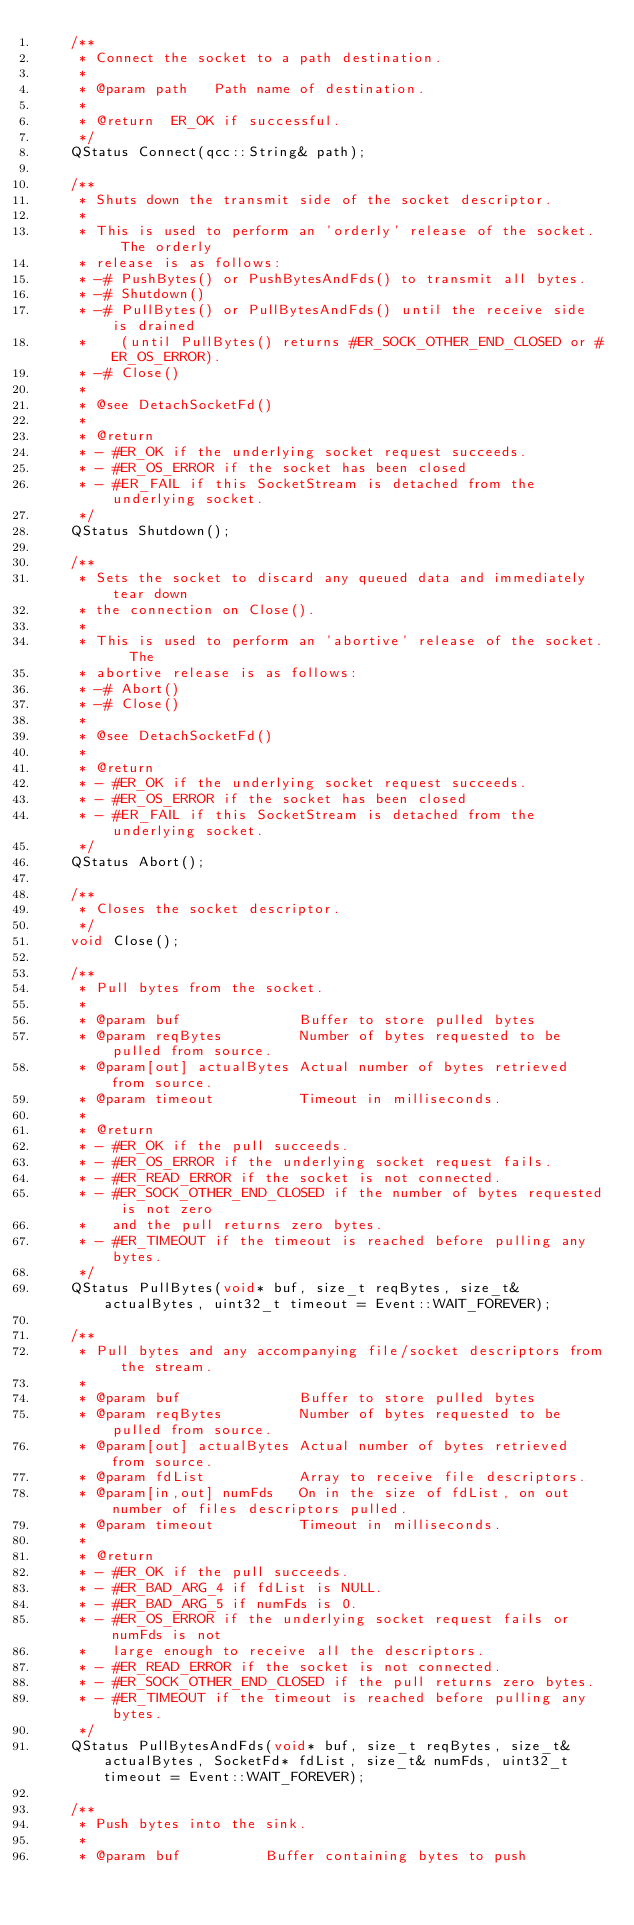Convert code to text. <code><loc_0><loc_0><loc_500><loc_500><_C_>    /**
     * Connect the socket to a path destination.
     *
     * @param path   Path name of destination.
     *
     * @return  ER_OK if successful.
     */
    QStatus Connect(qcc::String& path);

    /**
     * Shuts down the transmit side of the socket descriptor.
     *
     * This is used to perform an 'orderly' release of the socket.  The orderly
     * release is as follows:
     * -# PushBytes() or PushBytesAndFds() to transmit all bytes.
     * -# Shutdown()
     * -# PullBytes() or PullBytesAndFds() until the receive side is drained
     *    (until PullBytes() returns #ER_SOCK_OTHER_END_CLOSED or #ER_OS_ERROR).
     * -# Close()
     *
     * @see DetachSocketFd()
     *
     * @return
     * - #ER_OK if the underlying socket request succeeds.
     * - #ER_OS_ERROR if the socket has been closed
     * - #ER_FAIL if this SocketStream is detached from the underlying socket.
     */
    QStatus Shutdown();

    /**
     * Sets the socket to discard any queued data and immediately tear down
     * the connection on Close().
     *
     * This is used to perform an 'abortive' release of the socket.  The
     * abortive release is as follows:
     * -# Abort()
     * -# Close()
     *
     * @see DetachSocketFd()
     *
     * @return
     * - #ER_OK if the underlying socket request succeeds.
     * - #ER_OS_ERROR if the socket has been closed
     * - #ER_FAIL if this SocketStream is detached from the underlying socket.
     */
    QStatus Abort();

    /**
     * Closes the socket descriptor.
     */
    void Close();

    /**
     * Pull bytes from the socket.
     *
     * @param buf              Buffer to store pulled bytes
     * @param reqBytes         Number of bytes requested to be pulled from source.
     * @param[out] actualBytes Actual number of bytes retrieved from source.
     * @param timeout          Timeout in milliseconds.
     *
     * @return
     * - #ER_OK if the pull succeeds.
     * - #ER_OS_ERROR if the underlying socket request fails.
     * - #ER_READ_ERROR if the socket is not connected.
     * - #ER_SOCK_OTHER_END_CLOSED if the number of bytes requested is not zero
     *   and the pull returns zero bytes.
     * - #ER_TIMEOUT if the timeout is reached before pulling any bytes.
     */
    QStatus PullBytes(void* buf, size_t reqBytes, size_t& actualBytes, uint32_t timeout = Event::WAIT_FOREVER);

    /**
     * Pull bytes and any accompanying file/socket descriptors from the stream.
     *
     * @param buf              Buffer to store pulled bytes
     * @param reqBytes         Number of bytes requested to be pulled from source.
     * @param[out] actualBytes Actual number of bytes retrieved from source.
     * @param fdList           Array to receive file descriptors.
     * @param[in,out] numFds   On in the size of fdList, on out number of files descriptors pulled.
     * @param timeout          Timeout in milliseconds.
     *
     * @return
     * - #ER_OK if the pull succeeds.
     * - #ER_BAD_ARG_4 if fdList is NULL.
     * - #ER_BAD_ARG_5 if numFds is 0.
     * - #ER_OS_ERROR if the underlying socket request fails or numFds is not
     *   large enough to receive all the descriptors.
     * - #ER_READ_ERROR if the socket is not connected.
     * - #ER_SOCK_OTHER_END_CLOSED if the pull returns zero bytes.
     * - #ER_TIMEOUT if the timeout is reached before pulling any bytes.
     */
    QStatus PullBytesAndFds(void* buf, size_t reqBytes, size_t& actualBytes, SocketFd* fdList, size_t& numFds, uint32_t timeout = Event::WAIT_FOREVER);

    /**
     * Push bytes into the sink.
     *
     * @param buf          Buffer containing bytes to push</code> 